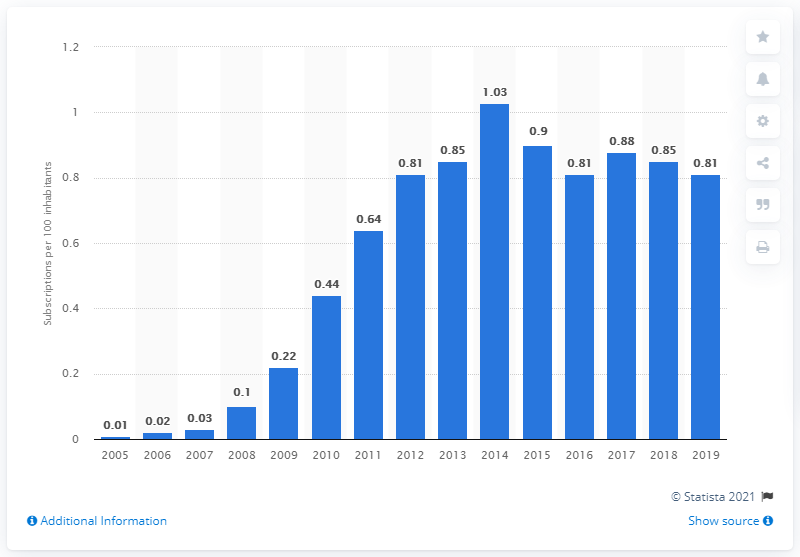Give some essential details in this illustration. During the period of 2005 to 2019, there were an estimated 0.81 fixed broadband subscriptions registered for every 100 inhabitants in Pakistan. 